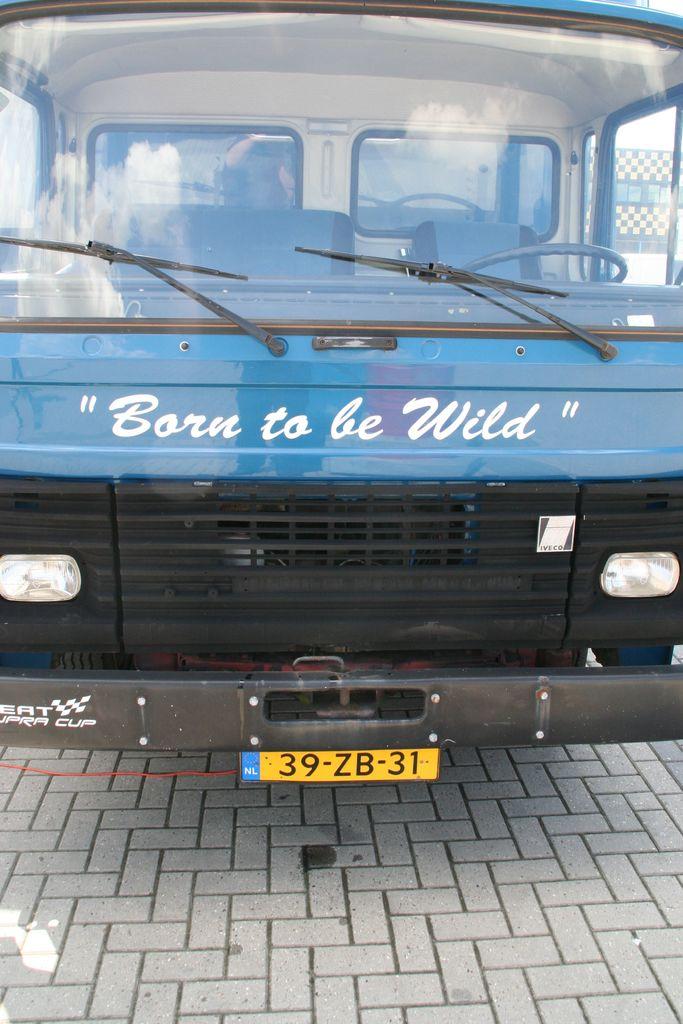What is the license plate number?
Ensure brevity in your answer.  39-zb-31. What does it say on the front grill?
Provide a short and direct response. Born to be wild. 